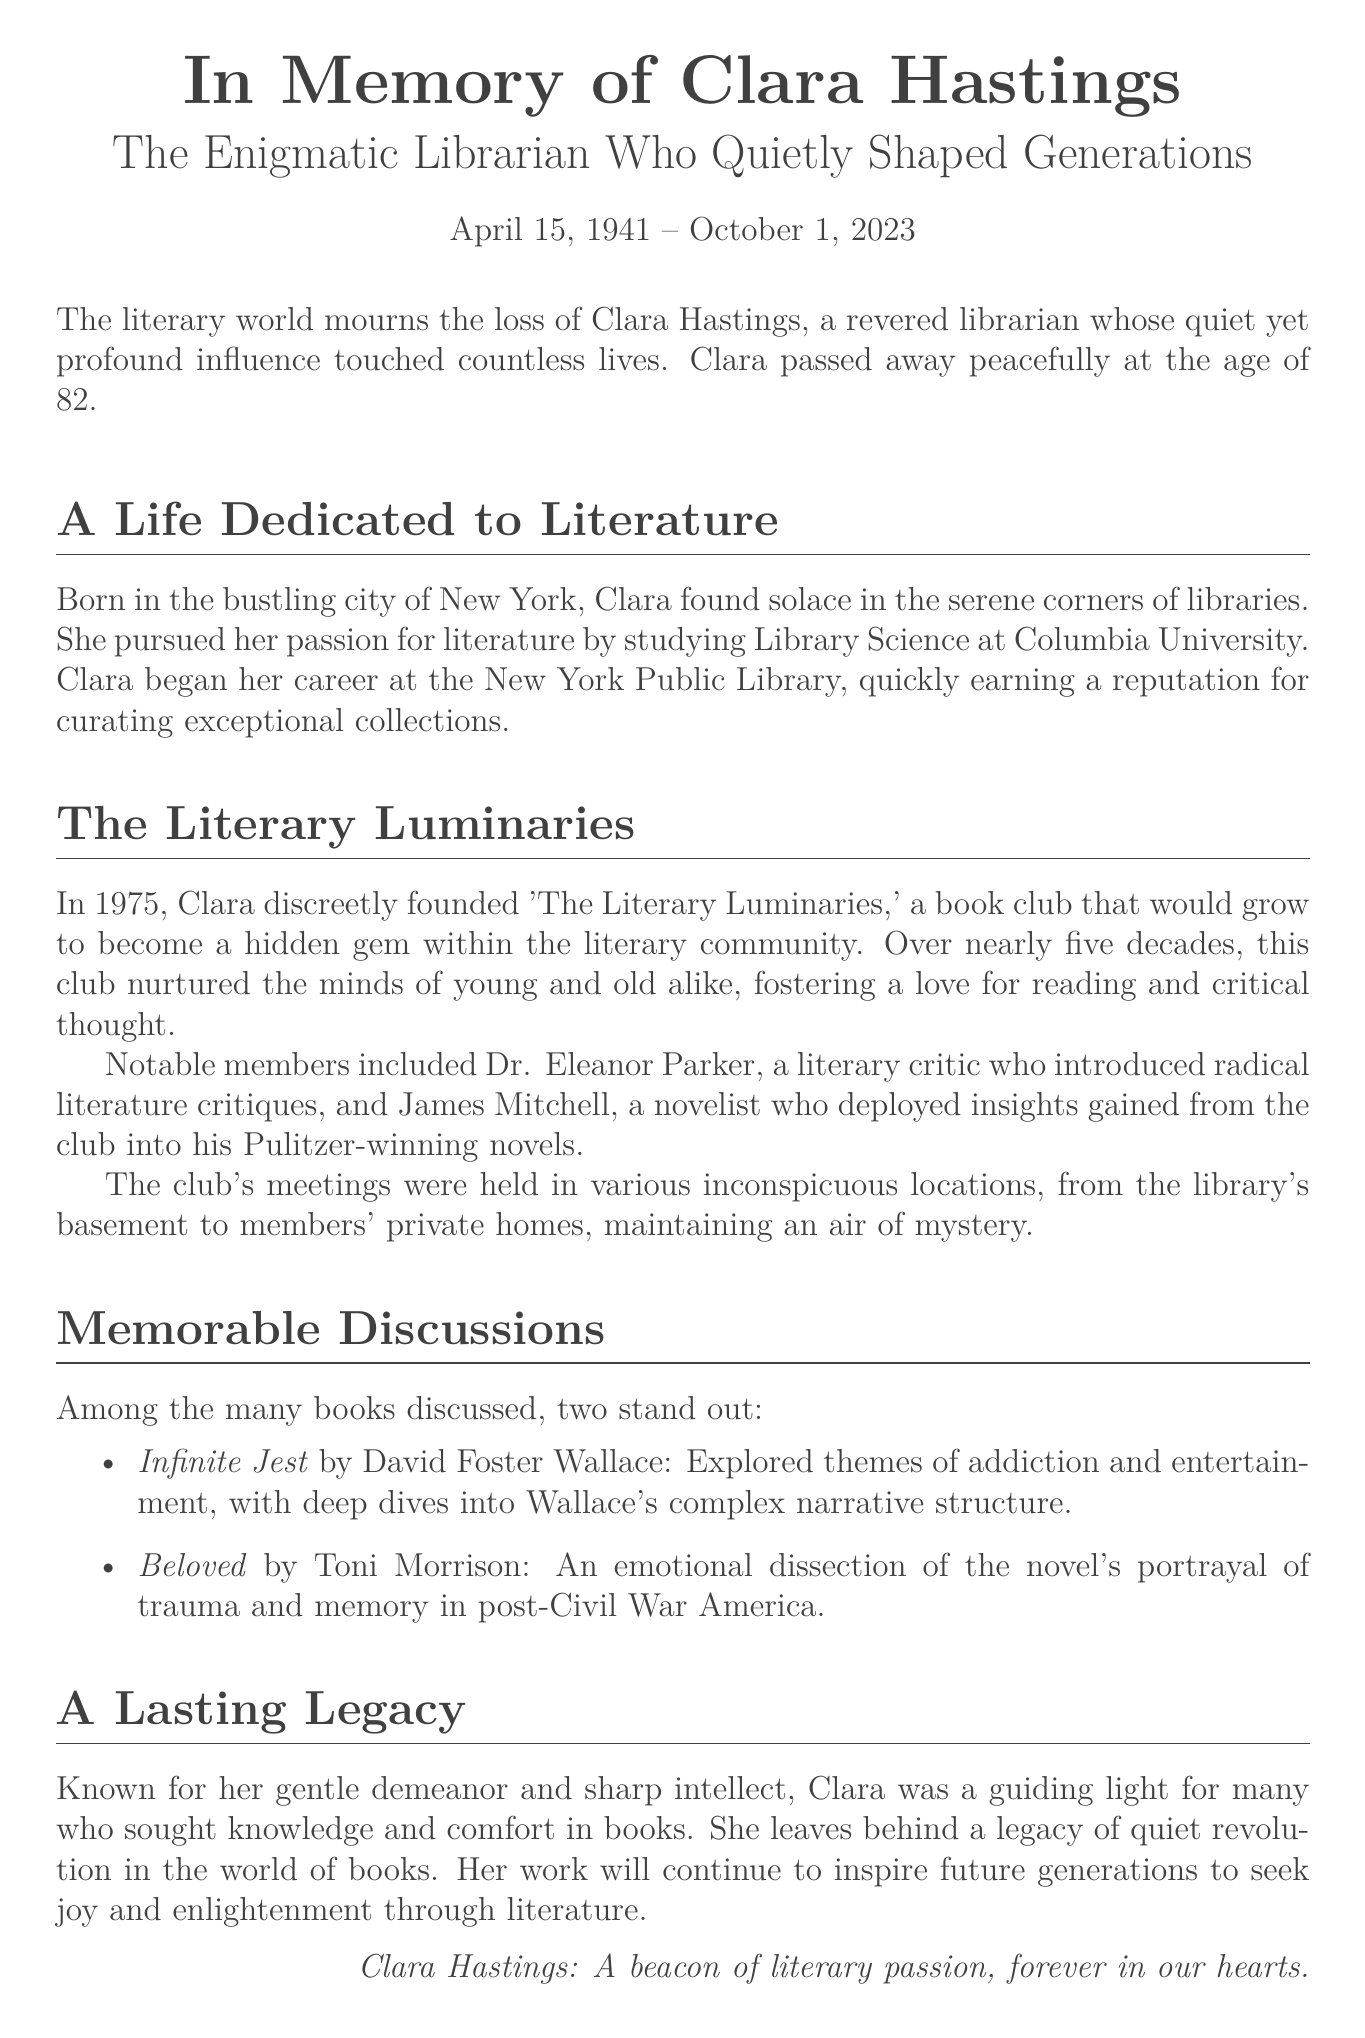What was Clara Hastings' profession? Clara Hastings was a librarian, as stated in the document.
Answer: librarian When was Clara Hastings born? The document states her birth date as April 15, 1941.
Answer: April 15, 1941 What is the name of the book club Clara founded? The book club founded by Clara is called 'The Literary Luminaries.'
Answer: The Literary Luminaries Who was a notable member of the book club? Notable members included Dr. Eleanor Parker and James Mitchell, as mentioned in the document.
Answer: Dr. Eleanor Parker What year was 'The Literary Luminaries' founded? The document indicates that the book club was founded in 1975.
Answer: 1975 What book discussed themes of addiction and entertainment? The document specifies that 'Infinite Jest' by David Foster Wallace was discussed.
Answer: Infinite Jest What lasting impact did Clara Hastings have? Clara left behind a legacy of inspiring future generations to seek joy and enlightenment through literature.
Answer: quiet revolution Where did the book club hold its meetings? The club's meetings were held in various inconspicuous locations mentioned in the document.
Answer: library's basement How old was Clara Hastings at the time of her passing? The document states Clara passed away at the age of 82.
Answer: 82 